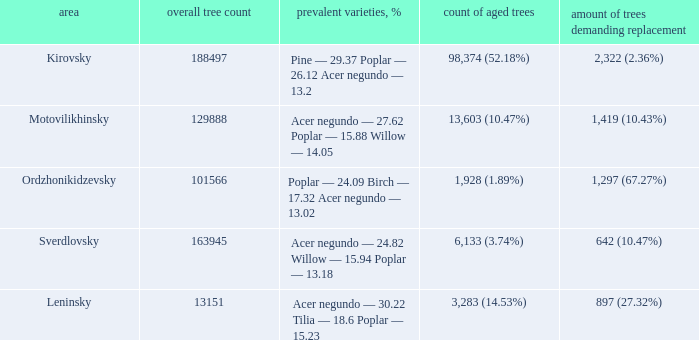What is the amount of trees, that require replacement when the district is motovilikhinsky? 1,419 (10.43%). 